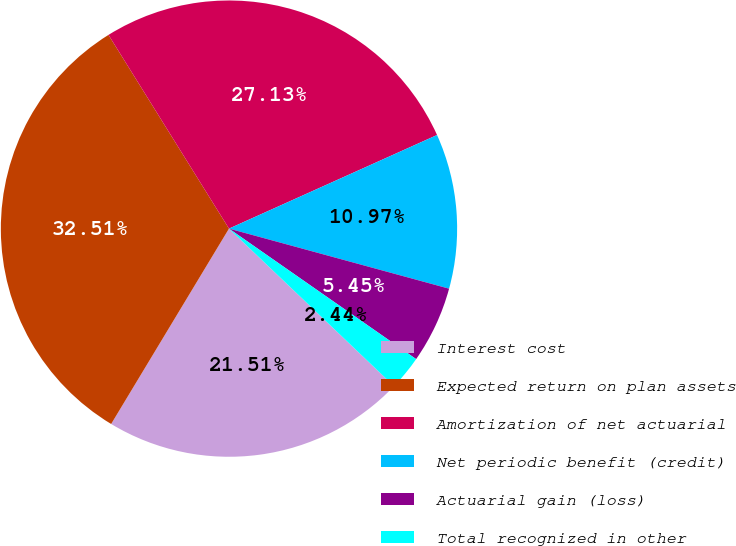Convert chart. <chart><loc_0><loc_0><loc_500><loc_500><pie_chart><fcel>Interest cost<fcel>Expected return on plan assets<fcel>Amortization of net actuarial<fcel>Net periodic benefit (credit)<fcel>Actuarial gain (loss)<fcel>Total recognized in other<nl><fcel>21.51%<fcel>32.51%<fcel>27.13%<fcel>10.97%<fcel>5.45%<fcel>2.44%<nl></chart> 